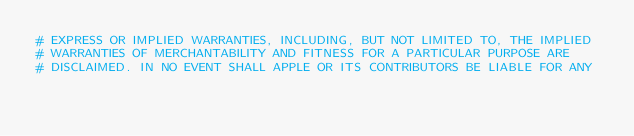<code> <loc_0><loc_0><loc_500><loc_500><_Python_># EXPRESS OR IMPLIED WARRANTIES, INCLUDING, BUT NOT LIMITED TO, THE IMPLIED
# WARRANTIES OF MERCHANTABILITY AND FITNESS FOR A PARTICULAR PURPOSE ARE
# DISCLAIMED. IN NO EVENT SHALL APPLE OR ITS CONTRIBUTORS BE LIABLE FOR ANY</code> 